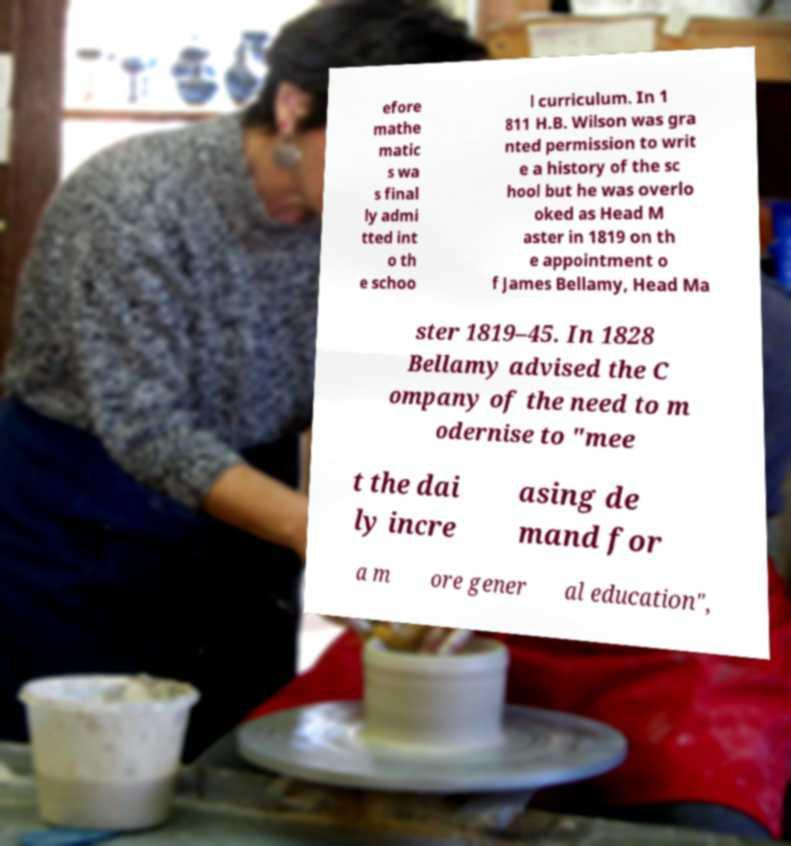Can you accurately transcribe the text from the provided image for me? efore mathe matic s wa s final ly admi tted int o th e schoo l curriculum. In 1 811 H.B. Wilson was gra nted permission to writ e a history of the sc hool but he was overlo oked as Head M aster in 1819 on th e appointment o f James Bellamy, Head Ma ster 1819–45. In 1828 Bellamy advised the C ompany of the need to m odernise to "mee t the dai ly incre asing de mand for a m ore gener al education", 